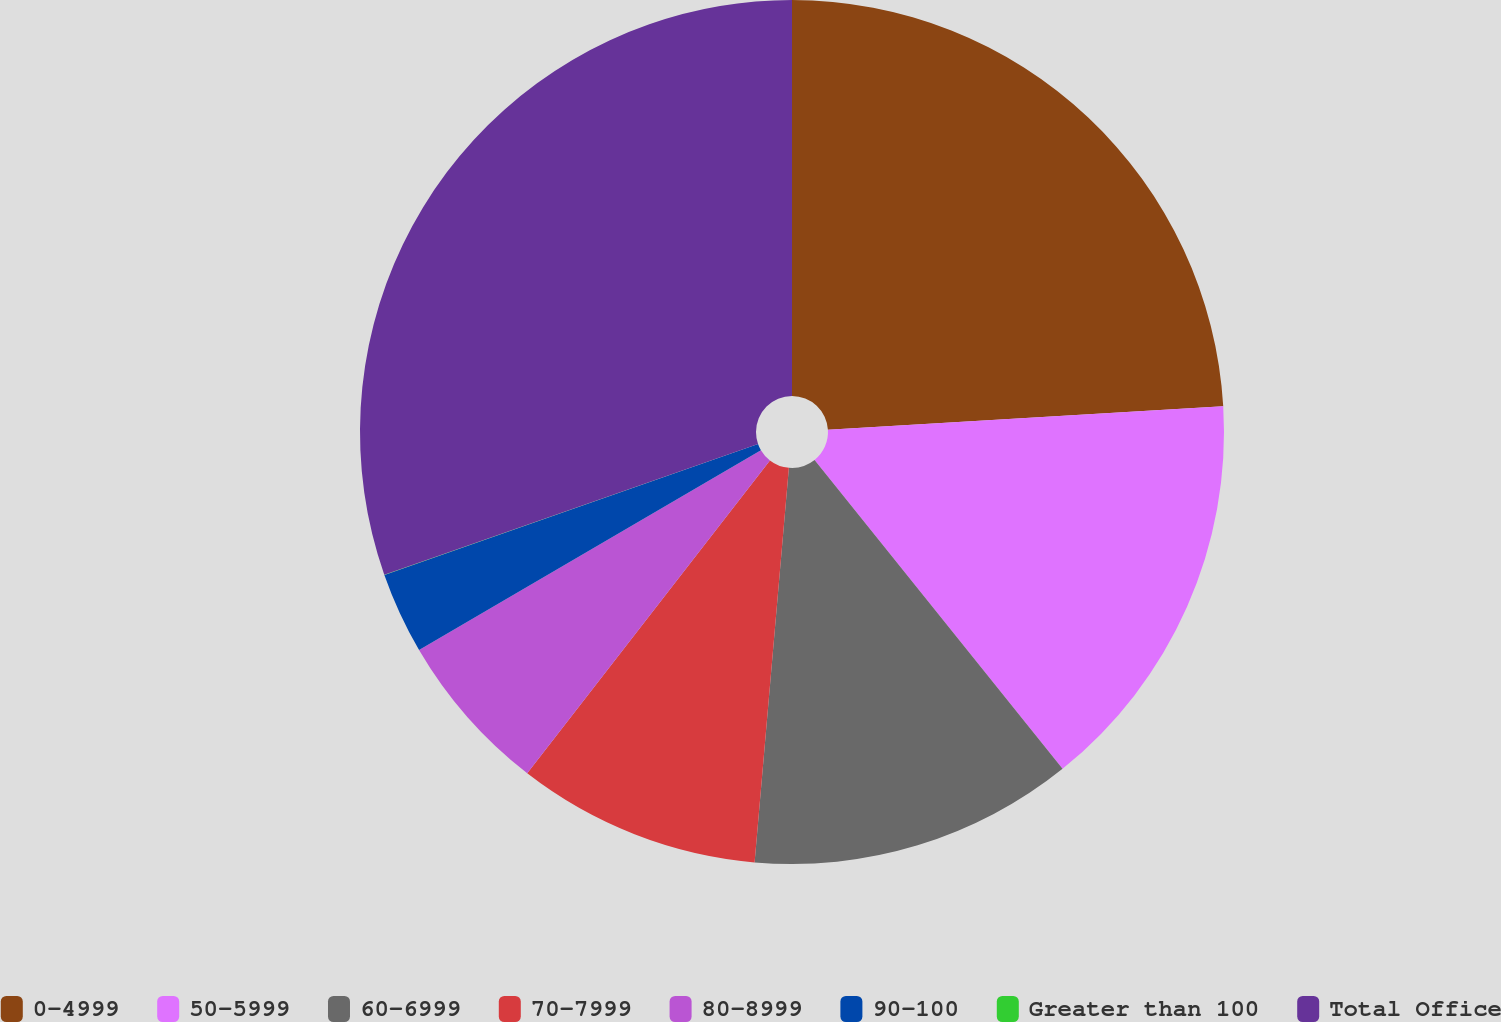Convert chart. <chart><loc_0><loc_0><loc_500><loc_500><pie_chart><fcel>0-4999<fcel>50-5999<fcel>60-6999<fcel>70-7999<fcel>80-8999<fcel>90-100<fcel>Greater than 100<fcel>Total Office<nl><fcel>24.05%<fcel>15.18%<fcel>12.15%<fcel>9.12%<fcel>6.08%<fcel>3.05%<fcel>0.01%<fcel>30.36%<nl></chart> 